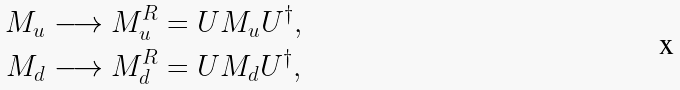Convert formula to latex. <formula><loc_0><loc_0><loc_500><loc_500>M _ { u } & \longrightarrow M _ { u } ^ { R } = U M _ { u } U ^ { \dag } , \\ M _ { d } & \longrightarrow M _ { d } ^ { R } = U M _ { d } U ^ { \dag } ,</formula> 